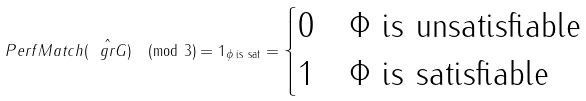Convert formula to latex. <formula><loc_0><loc_0><loc_500><loc_500>P e r f M a t c h ( \hat { \ g r G } ) \pmod { 3 } = 1 _ { \phi \text { is sat} } = \begin{cases} 0 & \Phi \text { is unsatisfiable} \\ 1 & \Phi \text { is satisfiable} \\ \end{cases}</formula> 